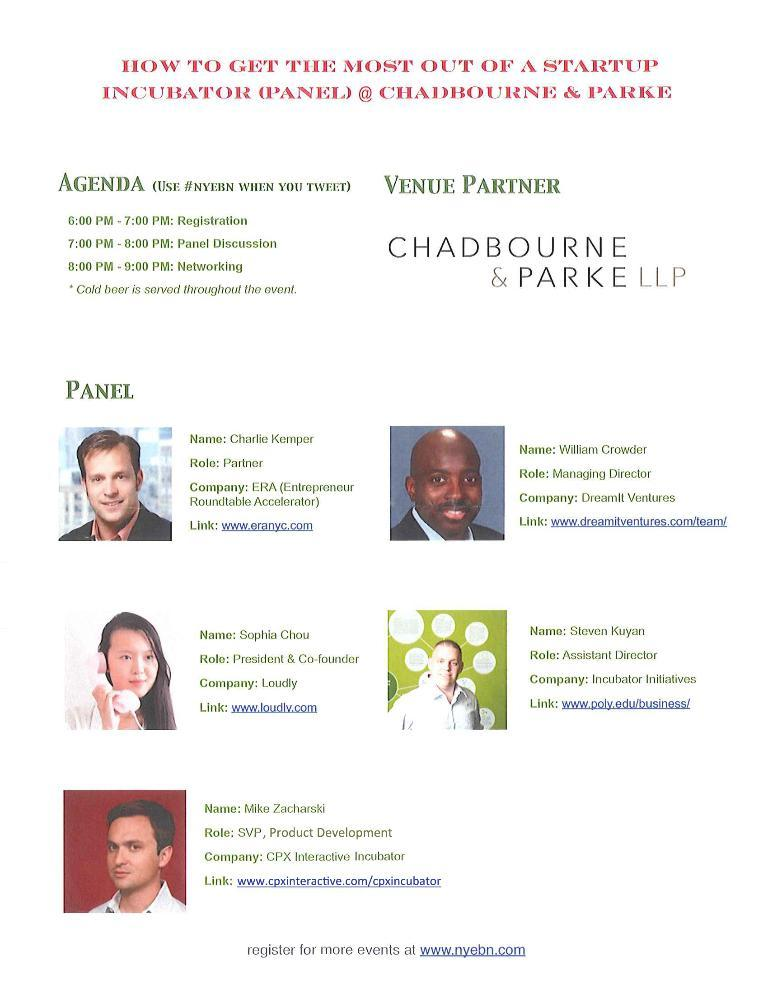What is the main subject of the image? The main subject of the image is a page from a book. What can be found on the page? The page includes pictures and text. What type of trains can be seen in the image? There are no trains present in the image; it features a page from a book with pictures and text. What time of day is depicted in the image? The image does not depict a specific time of day; it is a page from a book with pictures and text. 